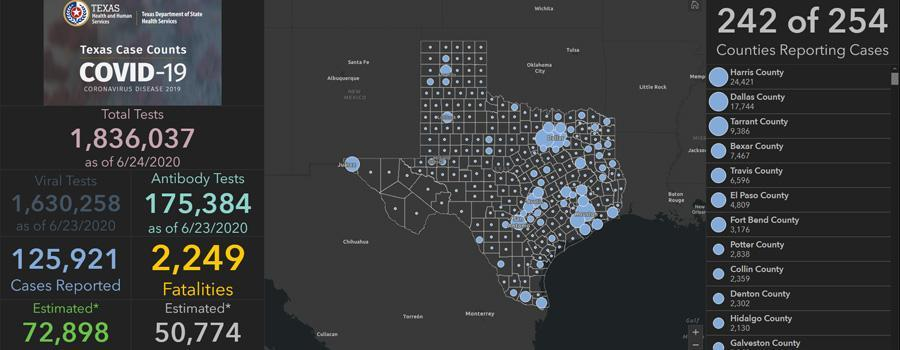What is the difference between the case reported in Harris and Dallas counties?
Answer the question with a short phrase. 6677 What is the total case reported in Travis and Potter county, taken together? 9434 What is the difference between the estimated case reported and estimated fatalities? 22124 What is the difference between the case reported and fatalities? 123672 